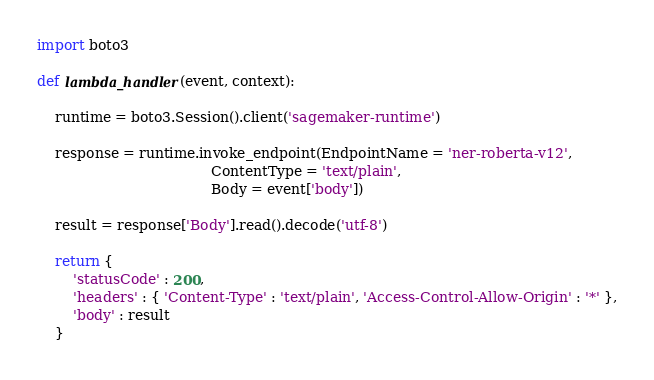Convert code to text. <code><loc_0><loc_0><loc_500><loc_500><_Python_>import boto3

def lambda_handler(event, context):

    runtime = boto3.Session().client('sagemaker-runtime')

    response = runtime.invoke_endpoint(EndpointName = 'ner-roberta-v12',    
                                       ContentType = 'text/plain',                
                                       Body = event['body'])                       

    result = response['Body'].read().decode('utf-8')

    return {
        'statusCode' : 200,
        'headers' : { 'Content-Type' : 'text/plain', 'Access-Control-Allow-Origin' : '*' },
        'body' : result
    }</code> 